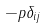Convert formula to latex. <formula><loc_0><loc_0><loc_500><loc_500>- p \delta _ { i j }</formula> 